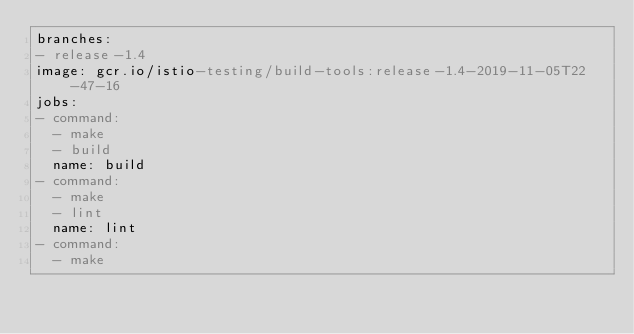Convert code to text. <code><loc_0><loc_0><loc_500><loc_500><_YAML_>branches:
- release-1.4
image: gcr.io/istio-testing/build-tools:release-1.4-2019-11-05T22-47-16
jobs:
- command:
  - make
  - build
  name: build
- command:
  - make
  - lint
  name: lint
- command:
  - make</code> 